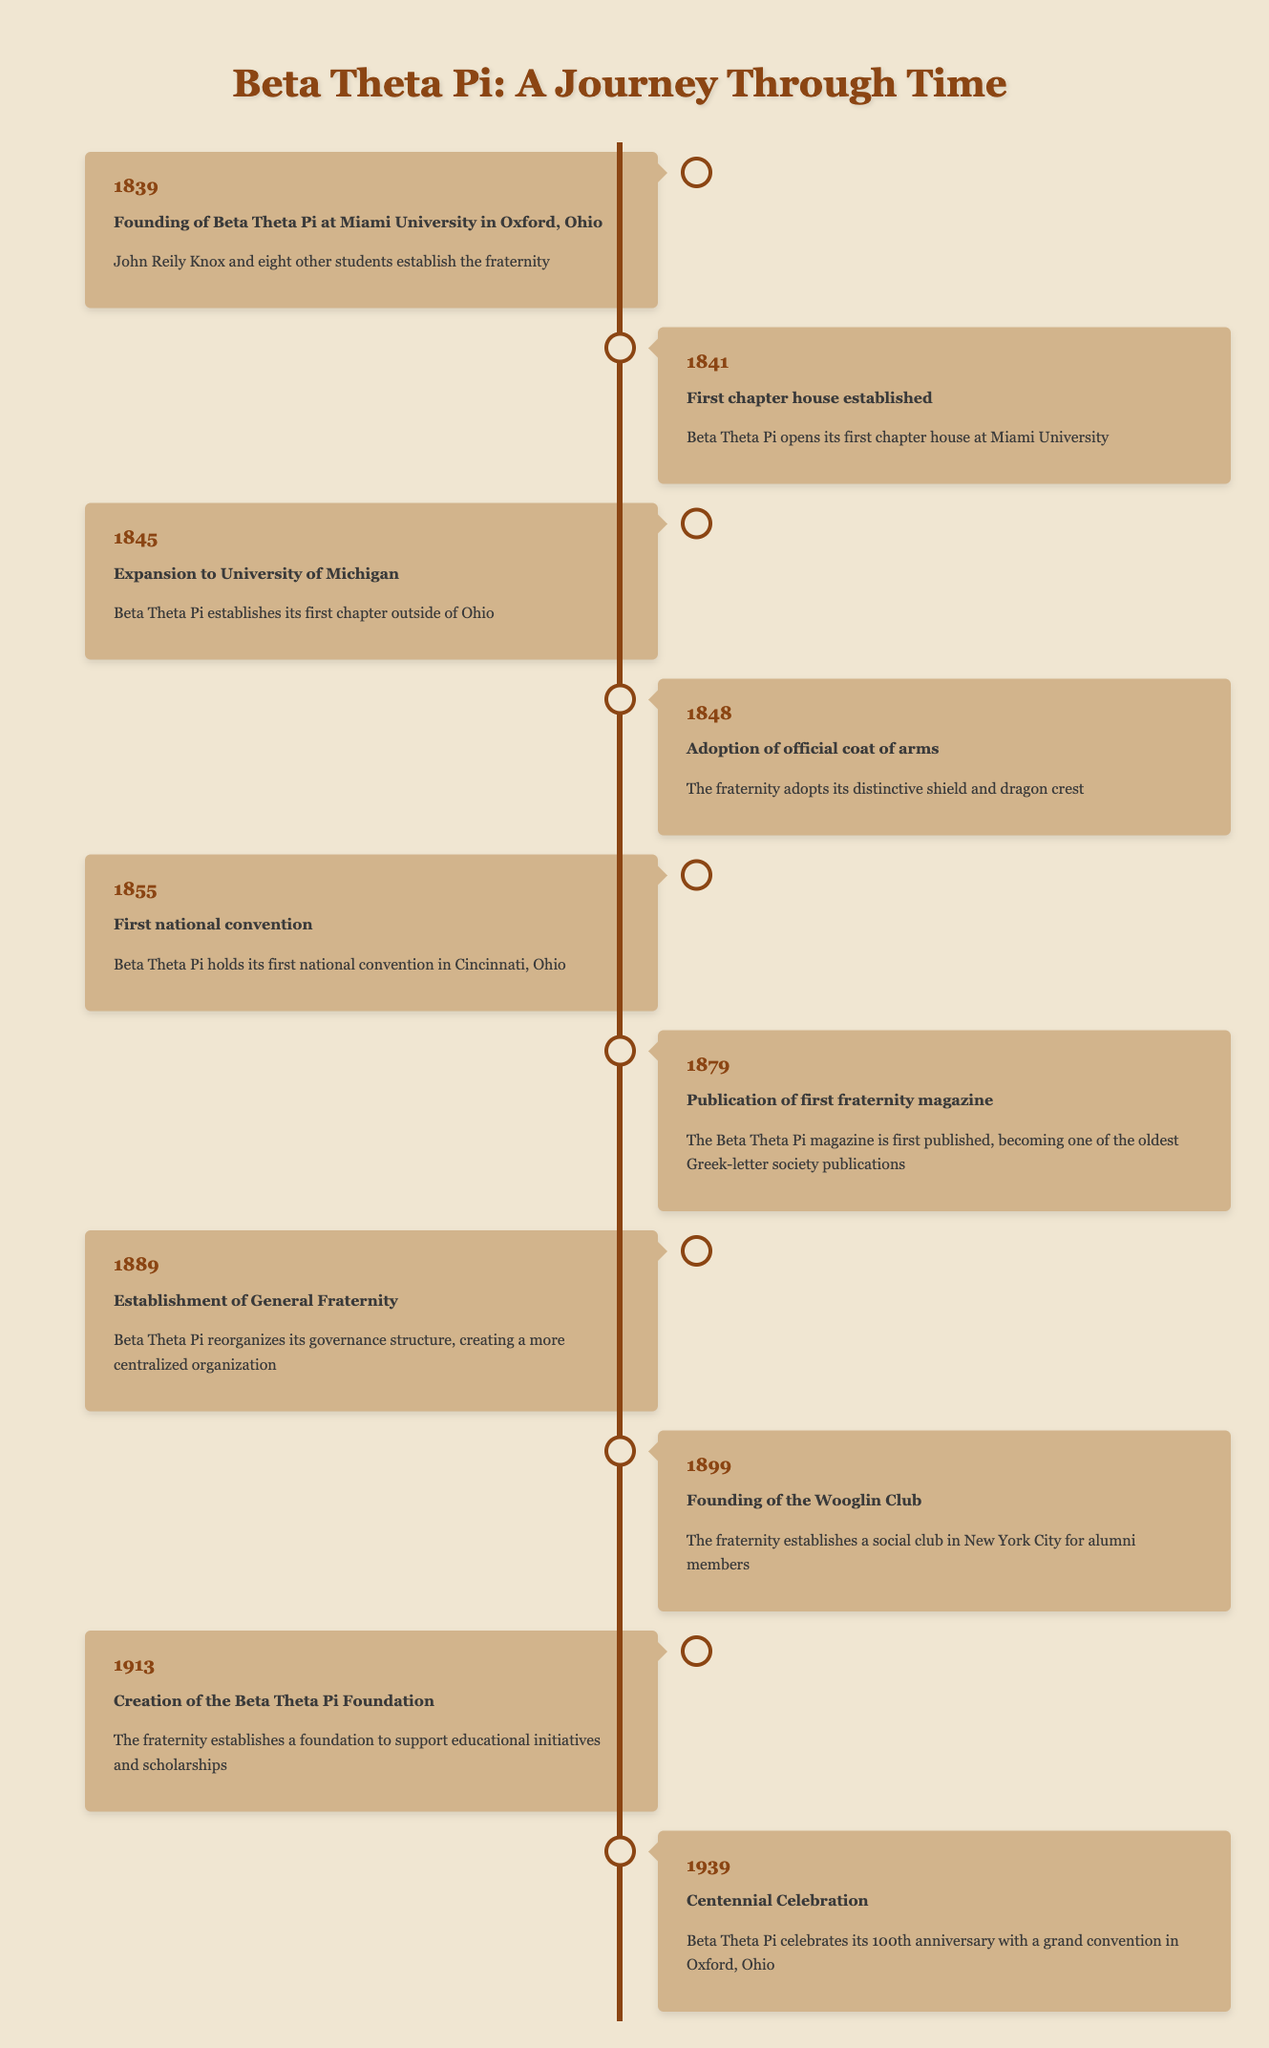What year was Beta Theta Pi founded? The founding event is listed in the first entry of the timeline, which shows the year 1839 as the founding year of Beta Theta Pi at Miami University in Oxford, Ohio.
Answer: 1839 Which event occurred first, the establishment of the first chapter house or the expansion to the University of Michigan? The first chapter house was established in 1841, while the expansion to the University of Michigan occurred in 1845. Since 1841 is earlier than 1845, the first chapter house was established first.
Answer: First chapter house What significant structural change happened in 1889? The timeline indicates that in 1889, Beta Theta Pi reorganized its governance structure, leading to the establishment of the General Fraternity. This represents a significant change in how the fraternity was governed.
Answer: Establishment of General Fraternity How many years apart were the founding of the fraternity and the centennial celebration? The fraternity was founded in 1839 and celebrated its centennial in 1939. To find the difference in years, subtract 1839 from 1939, which gives us 100 years apart.
Answer: 100 years Was the first publication of the fraternity magazine before or after the first national convention? The first national convention occurred in 1855 whereas the first fraternity magazine was published in 1879. Since 1855 comes before 1879, the magazine was published after the national convention.
Answer: After How many key events are listed in the timeline? The timeline contains a total of 10 distinct events, each marked by a specific year and description.
Answer: 10 events In what year did Beta Theta Pi adopt its official coat of arms? According to the timeline, the fraternity adopted its official coat of arms in the year 1848, as specified in that entry of the timeline.
Answer: 1848 What other significant social initiative was established in 1899 besides the founding of the Wooglin Club? The timeline does not indicate any other significant social initiative besides the founding of the Wooglin Club in 1899. Thus, the Wooglin Club is the only event for that year.
Answer: None What is the average year of all key events listed in the timeline? To find the average, sum all years: (1839 + 1841 + 1845 + 1848 + 1855 + 1879 + 1889 + 1899 + 1913 + 1939) = 18758. There are 10 events, so the average is 18758 divided by 10, which equals 1875.8, thus rounding gives us 1876.
Answer: 1876 